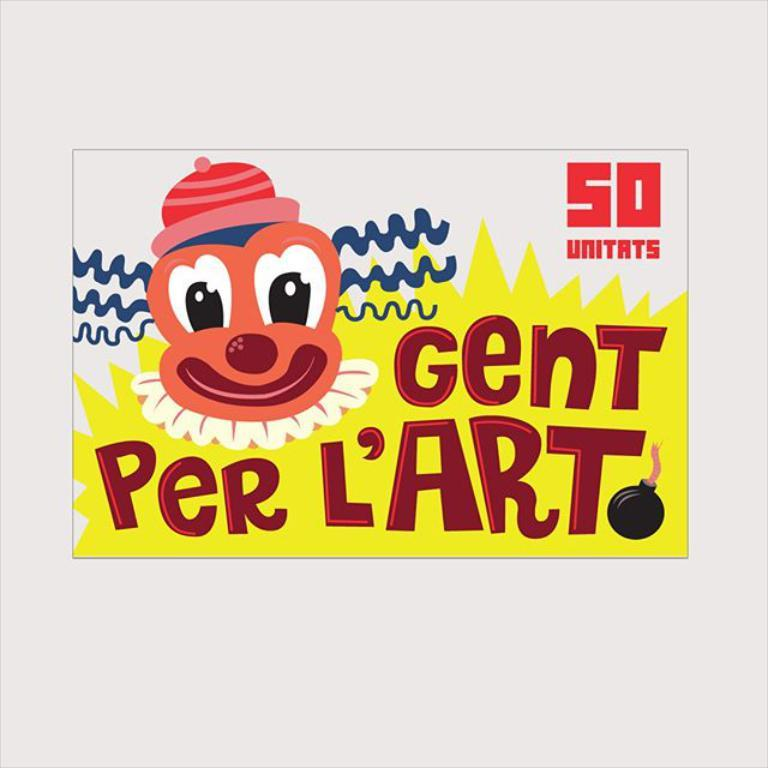What elements are present on the poster in the image? The poster contains text and an image. Can you describe the text on the poster? Unfortunately, the specific content of the text cannot be determined from the provided facts. What is the subject of the image on the poster? The specific subject of the image on the poster cannot be determined from the provided facts. What month is depicted in the image on the poster? There is no month depicted in the image on the poster, as the provided facts only mention that the poster contains an image and text. 